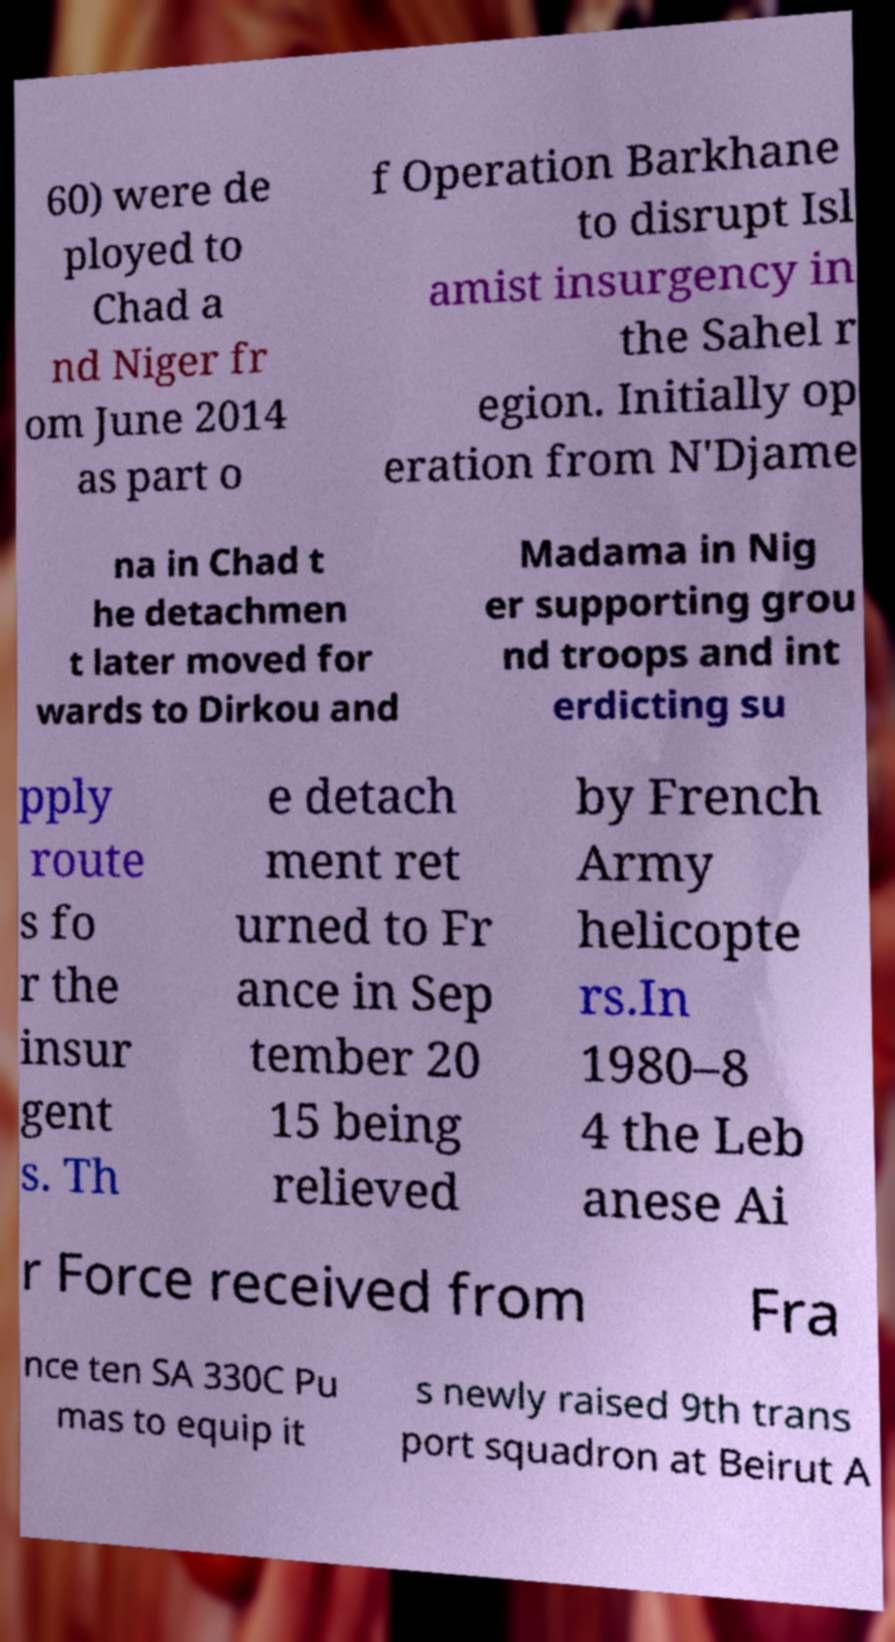Can you read and provide the text displayed in the image?This photo seems to have some interesting text. Can you extract and type it out for me? 60) were de ployed to Chad a nd Niger fr om June 2014 as part o f Operation Barkhane to disrupt Isl amist insurgency in the Sahel r egion. Initially op eration from N'Djame na in Chad t he detachmen t later moved for wards to Dirkou and Madama in Nig er supporting grou nd troops and int erdicting su pply route s fo r the insur gent s. Th e detach ment ret urned to Fr ance in Sep tember 20 15 being relieved by French Army helicopte rs.In 1980–8 4 the Leb anese Ai r Force received from Fra nce ten SA 330C Pu mas to equip it s newly raised 9th trans port squadron at Beirut A 